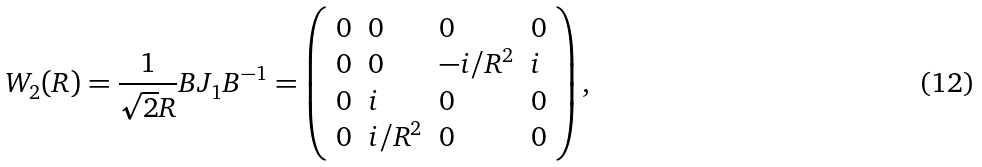Convert formula to latex. <formula><loc_0><loc_0><loc_500><loc_500>W _ { 2 } ( R ) = { \frac { 1 } { \sqrt { 2 } R } } B J _ { 1 } B ^ { - 1 } = \left ( \begin{array} { l l l l } { 0 } & { 0 } & { 0 } & { 0 } \\ { 0 } & { 0 } & { { - i / R ^ { 2 } } } & { i } \\ { 0 } & { i } & { 0 } & { 0 } \\ { 0 } & { { i / R ^ { 2 } } } & { 0 } & { 0 } \end{array} \right ) ,</formula> 